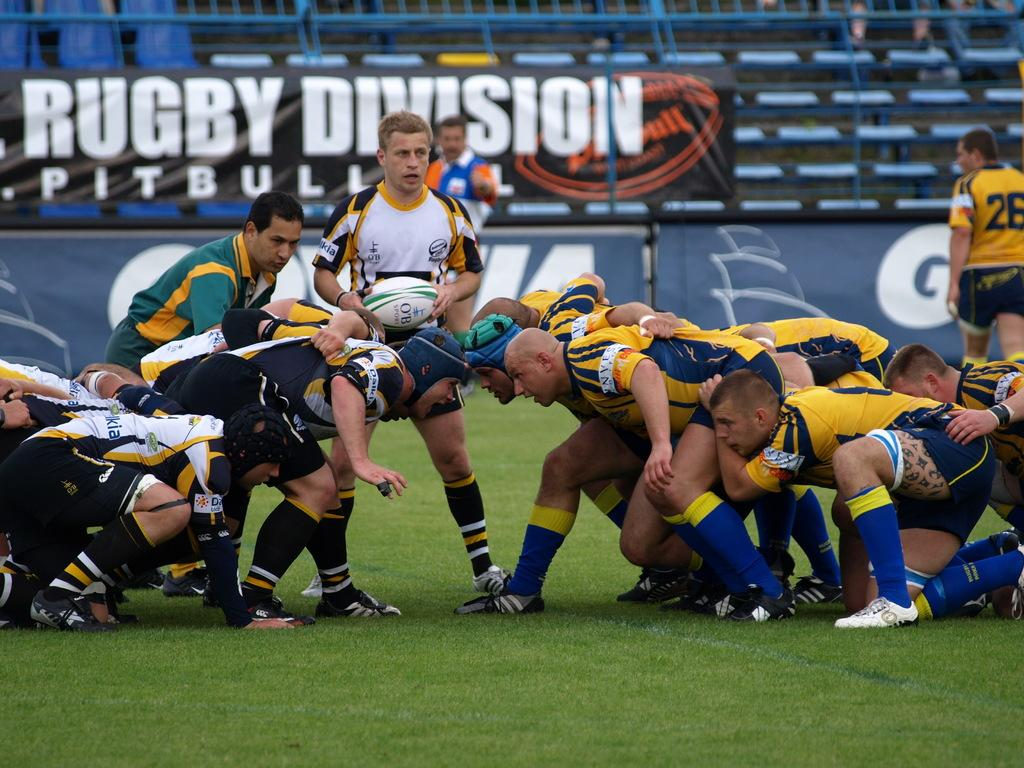What are the people in the image doing? The people in the image are playing rugby. What type of surface are they playing on? The ground is green and grassy. What type of fork can be seen in the image? There is no fork present in the image; it features people playing rugby on a grassy field. How do the players feel about the game? The image does not convey the players' feelings or emotions. 